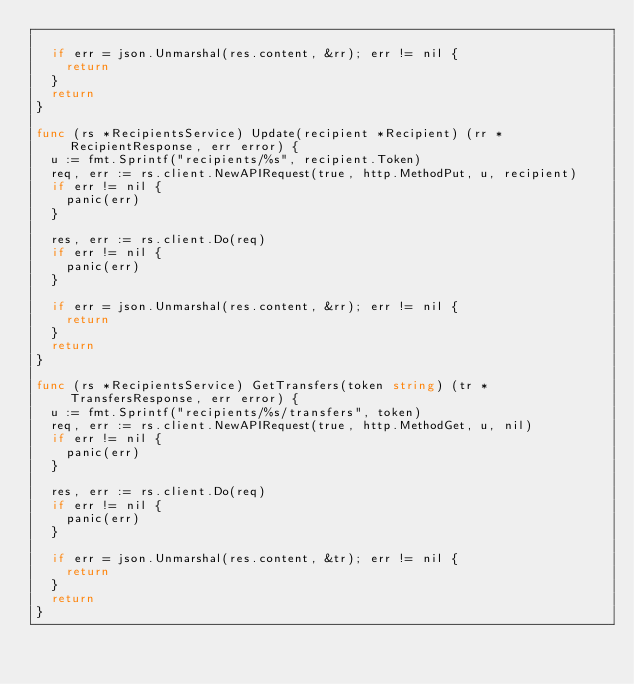Convert code to text. <code><loc_0><loc_0><loc_500><loc_500><_Go_>
	if err = json.Unmarshal(res.content, &rr); err != nil {
		return
	}
	return
}

func (rs *RecipientsService) Update(recipient *Recipient) (rr *RecipientResponse, err error) {
	u := fmt.Sprintf("recipients/%s", recipient.Token)
	req, err := rs.client.NewAPIRequest(true, http.MethodPut, u, recipient)
	if err != nil {
		panic(err)
	}

	res, err := rs.client.Do(req)
	if err != nil {
		panic(err)
	}

	if err = json.Unmarshal(res.content, &rr); err != nil {
		return
	}
	return
}

func (rs *RecipientsService) GetTransfers(token string) (tr *TransfersResponse, err error) {
	u := fmt.Sprintf("recipients/%s/transfers", token)
	req, err := rs.client.NewAPIRequest(true, http.MethodGet, u, nil)
	if err != nil {
		panic(err)
	}

	res, err := rs.client.Do(req)
	if err != nil {
		panic(err)
	}

	if err = json.Unmarshal(res.content, &tr); err != nil {
		return
	}
	return
}
</code> 